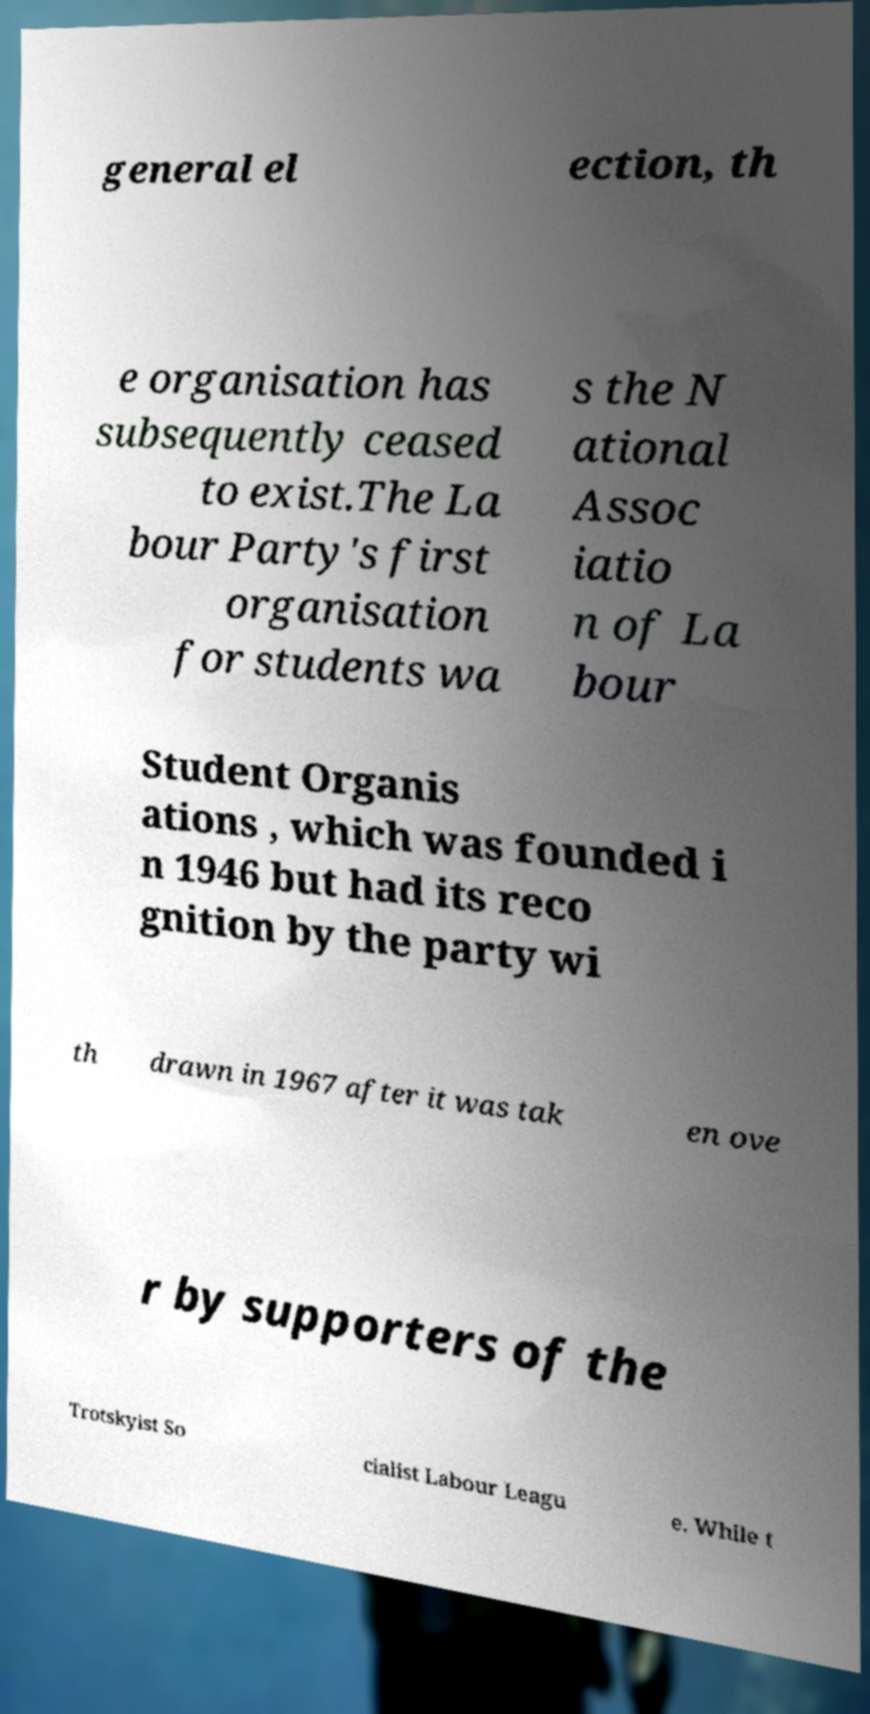There's text embedded in this image that I need extracted. Can you transcribe it verbatim? general el ection, th e organisation has subsequently ceased to exist.The La bour Party's first organisation for students wa s the N ational Assoc iatio n of La bour Student Organis ations , which was founded i n 1946 but had its reco gnition by the party wi th drawn in 1967 after it was tak en ove r by supporters of the Trotskyist So cialist Labour Leagu e. While t 